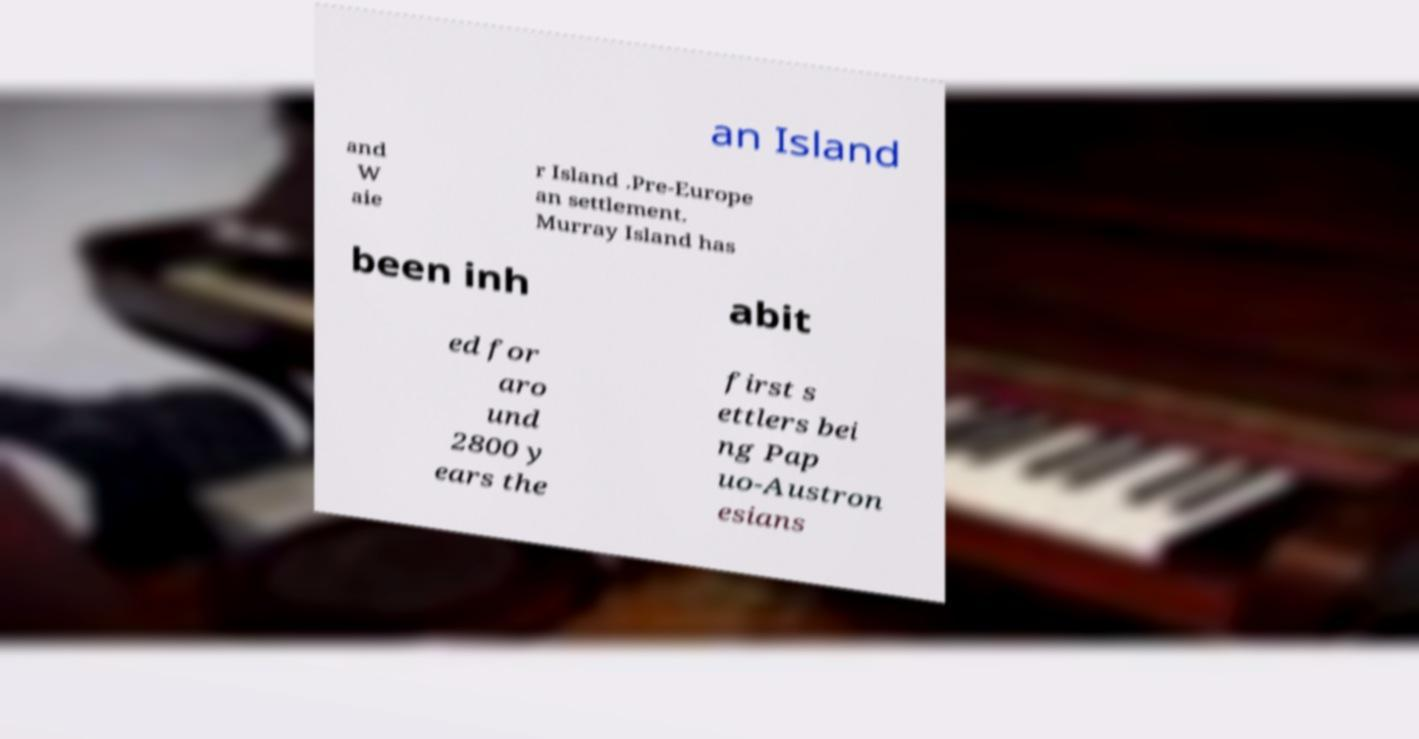I need the written content from this picture converted into text. Can you do that? an Island and W aie r Island .Pre-Europe an settlement. Murray Island has been inh abit ed for aro und 2800 y ears the first s ettlers bei ng Pap uo-Austron esians 